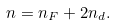Convert formula to latex. <formula><loc_0><loc_0><loc_500><loc_500>n = n _ { F } + 2 n _ { d } .</formula> 